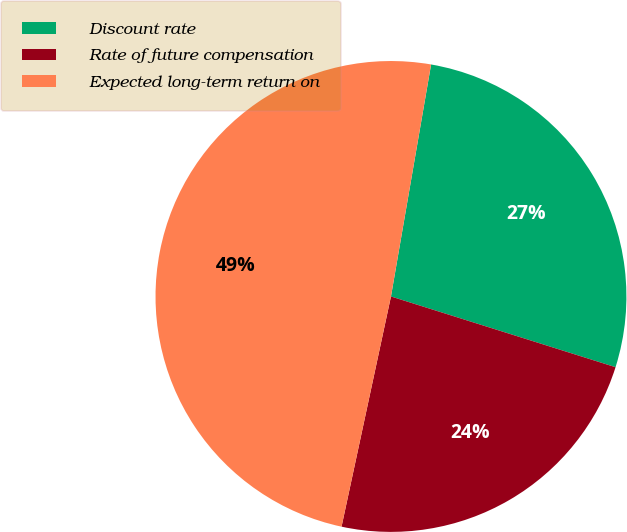Convert chart to OTSL. <chart><loc_0><loc_0><loc_500><loc_500><pie_chart><fcel>Discount rate<fcel>Rate of future compensation<fcel>Expected long-term return on<nl><fcel>27.13%<fcel>23.51%<fcel>49.36%<nl></chart> 